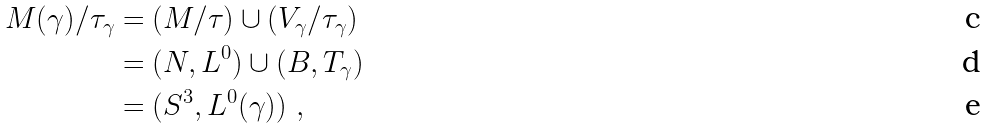Convert formula to latex. <formula><loc_0><loc_0><loc_500><loc_500>M ( \gamma ) / \tau _ { \gamma } & = ( M / \tau ) \cup ( V _ { \gamma } / \tau _ { \gamma } ) \\ & = ( N , L ^ { 0 } ) \cup ( B , T _ { \gamma } ) \\ & = ( S ^ { 3 } , L ^ { 0 } ( \gamma ) ) \ ,</formula> 